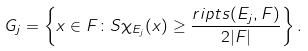Convert formula to latex. <formula><loc_0><loc_0><loc_500><loc_500>G _ { j } = \left \{ x \in F \colon S \chi _ { E _ { j } } ( x ) \geq \frac { r i p t s ( E _ { j } , F ) } { 2 | F | } \right \} .</formula> 